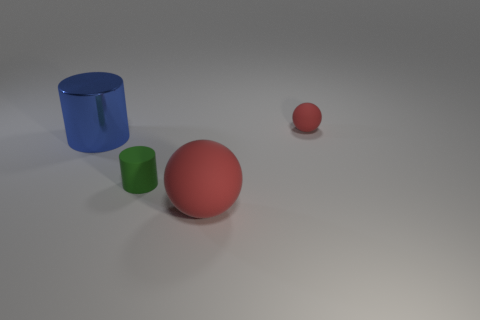Add 1 red matte cubes. How many objects exist? 5 Subtract all things. Subtract all tiny red metal cylinders. How many objects are left? 0 Add 2 small balls. How many small balls are left? 3 Add 4 matte spheres. How many matte spheres exist? 6 Subtract 0 cyan spheres. How many objects are left? 4 